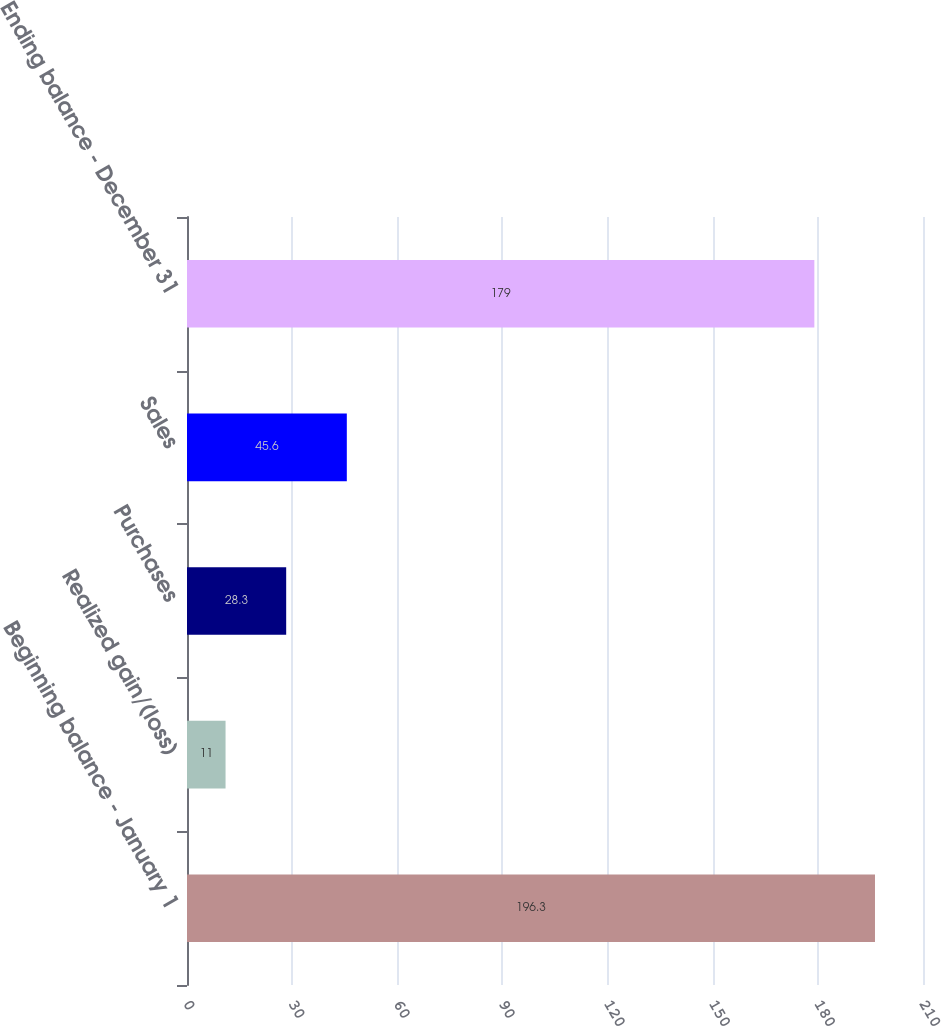Convert chart to OTSL. <chart><loc_0><loc_0><loc_500><loc_500><bar_chart><fcel>Beginning balance - January 1<fcel>Realized gain/(loss)<fcel>Purchases<fcel>Sales<fcel>Ending balance - December 31<nl><fcel>196.3<fcel>11<fcel>28.3<fcel>45.6<fcel>179<nl></chart> 